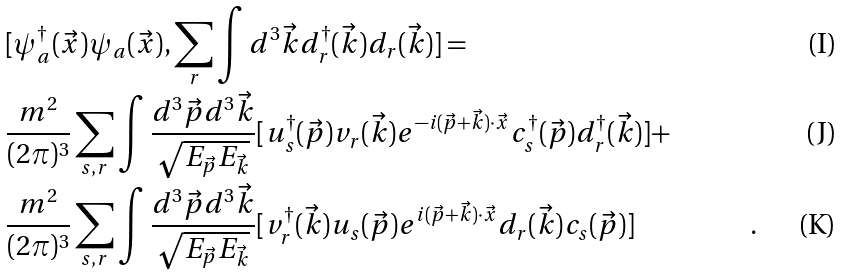<formula> <loc_0><loc_0><loc_500><loc_500>& [ \psi ^ { \dagger } _ { a } ( \vec { x } ) \psi _ { a } ( \vec { x } ) , \sum _ { r } \int { d ^ { 3 } \vec { k } } d ^ { \dagger } _ { r } ( \vec { k } ) d _ { r } ( \vec { k } ) ] = & \\ & \frac { m ^ { 2 } } { ( 2 \pi ) ^ { 3 } } \sum _ { s , r } \int \frac { { d ^ { 3 } \vec { p } } { d ^ { 3 } \vec { k } } } { \sqrt { E _ { \vec { p } } E _ { \vec { k } } } } [ u ^ { \dagger } _ { s } ( \vec { p } ) v _ { r } ( \vec { k } ) e ^ { - i ( \vec { p } + \vec { k } ) \cdot \vec { x } } c ^ { \dagger } _ { s } ( \vec { p } ) d ^ { \dagger } _ { r } ( \vec { k } ) ] + & \\ & \frac { m ^ { 2 } } { ( 2 \pi ) ^ { 3 } } \sum _ { s , r } \int \frac { { d ^ { 3 } \vec { p } } { d ^ { 3 } \vec { k } } } { \sqrt { E _ { \vec { p } } E _ { \vec { k } } } } [ v ^ { \dagger } _ { r } ( \vec { k } ) u _ { s } ( \vec { p } ) e ^ { i ( \vec { p } + \vec { k } ) \cdot \vec { x } } d _ { r } ( \vec { k } ) c _ { s } ( \vec { p } ) ] & .</formula> 